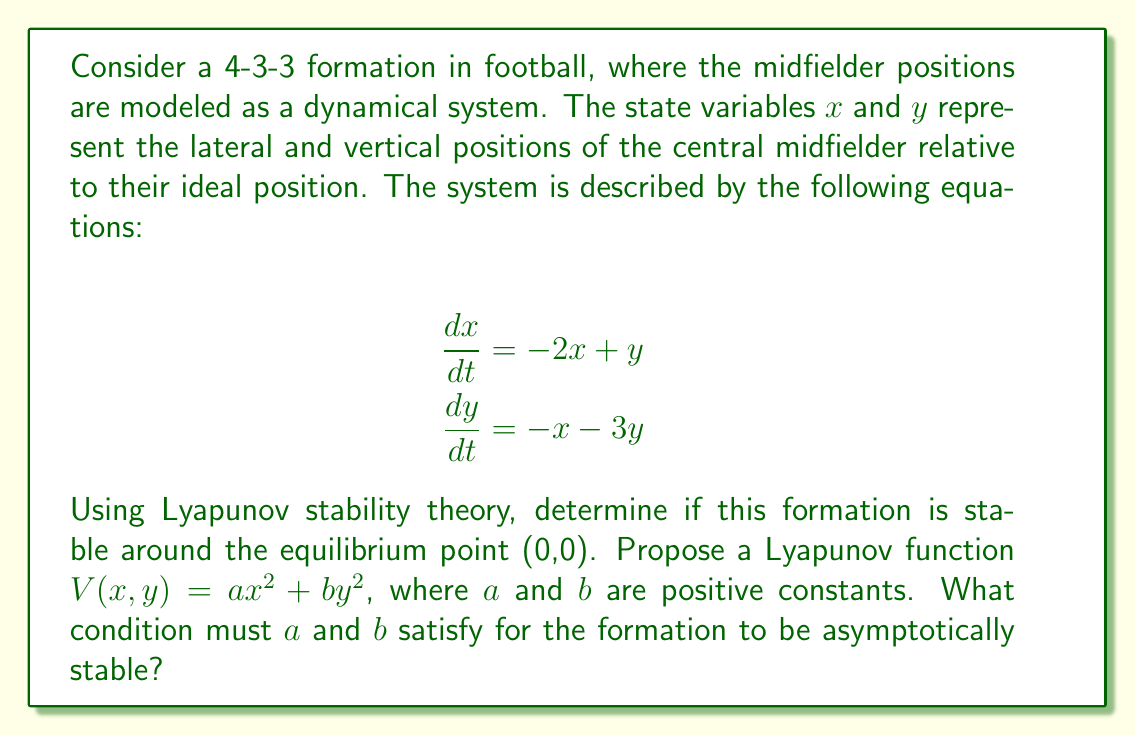Can you solve this math problem? To analyze the stability of the formation using Lyapunov stability theory, we'll follow these steps:

1) First, we need to ensure that $V(x,y) = ax^2 + by^2$ is positive definite. This is already satisfied since $a$ and $b$ are positive constants.

2) Next, we need to calculate $\frac{dV}{dt}$:

   $$\frac{dV}{dt} = \frac{\partial V}{\partial x}\frac{dx}{dt} + \frac{\partial V}{\partial y}\frac{dy}{dt}$$

3) Calculating the partial derivatives:
   
   $$\frac{\partial V}{\partial x} = 2ax$$
   $$\frac{\partial V}{\partial y} = 2by$$

4) Substituting these and the given equations for $\frac{dx}{dt}$ and $\frac{dy}{dt}$:

   $$\frac{dV}{dt} = 2ax(-2x+y) + 2by(-x-3y)$$

5) Expanding:

   $$\frac{dV}{dt} = -4ax^2 + 2axy - 2bxy - 6by^2$$

6) Factoring:

   $$\frac{dV}{dt} = -4ax^2 + 2(a-b)xy - 6by^2$$

7) For asymptotic stability, we need $\frac{dV}{dt}$ to be negative definite. This means the quadratic form must be negative definite. For a quadratic form $Ax^2 + 2Bxy + Cy^2$ to be negative definite, we need:

   $A < 0$, $C < 0$, and $AC > B^2$

8) In our case:
   $A = -4a$, $B = a-b$, $C = -6b$

9) The conditions become:
   $-4a < 0$ (already satisfied since $a > 0$)
   $-6b < 0$ (already satisfied since $b > 0$)
   $24ab > (a-b)^2$

Therefore, for asymptotic stability, $a$ and $b$ must satisfy:

$$24ab > (a-b)^2$$
Answer: $24ab > (a-b)^2$ 